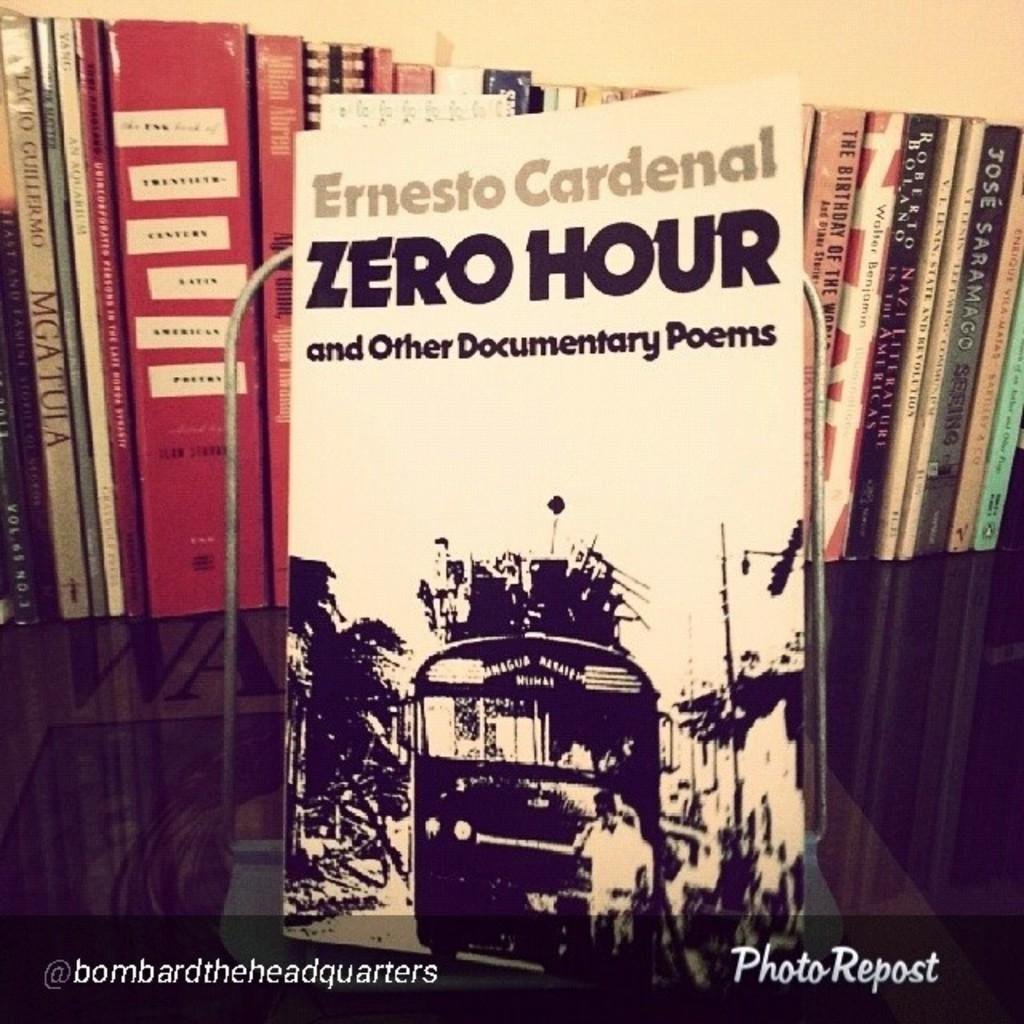<image>
Provide a brief description of the given image. A book called Zero Hour is on a shelf with other books. 